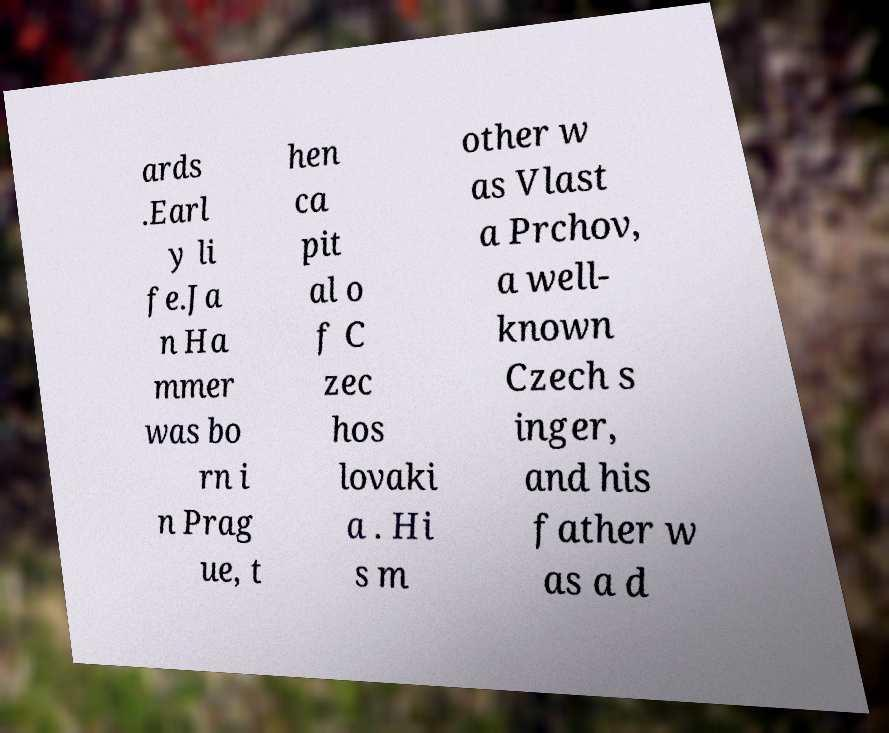Could you extract and type out the text from this image? ards .Earl y li fe.Ja n Ha mmer was bo rn i n Prag ue, t hen ca pit al o f C zec hos lovaki a . Hi s m other w as Vlast a Prchov, a well- known Czech s inger, and his father w as a d 